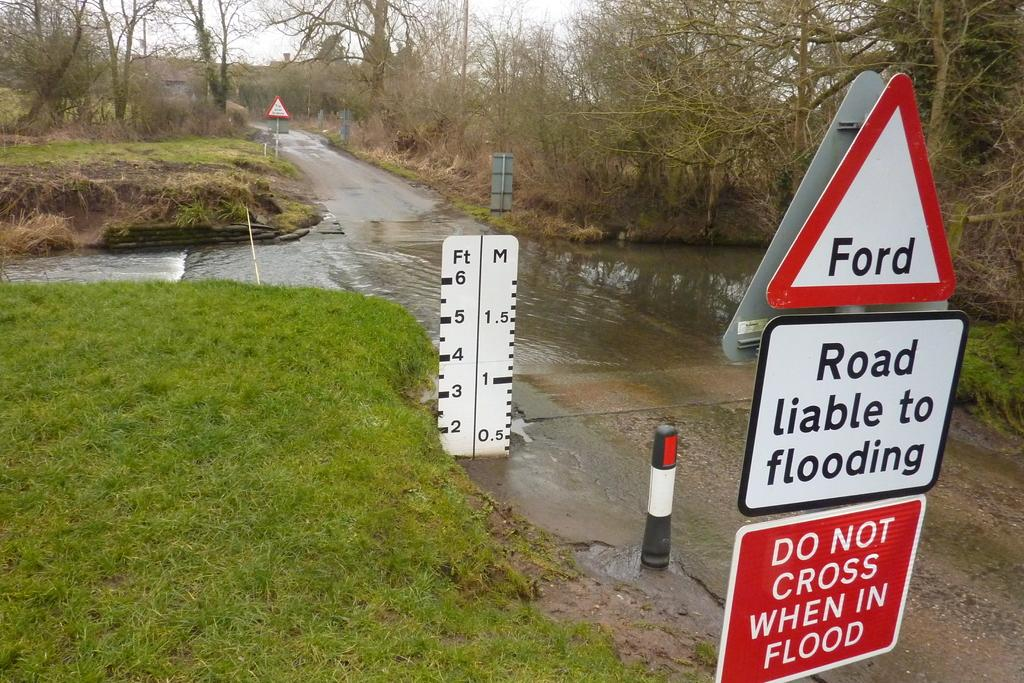<image>
Relay a brief, clear account of the picture shown. An intersection with signs warning about potential flooding. 